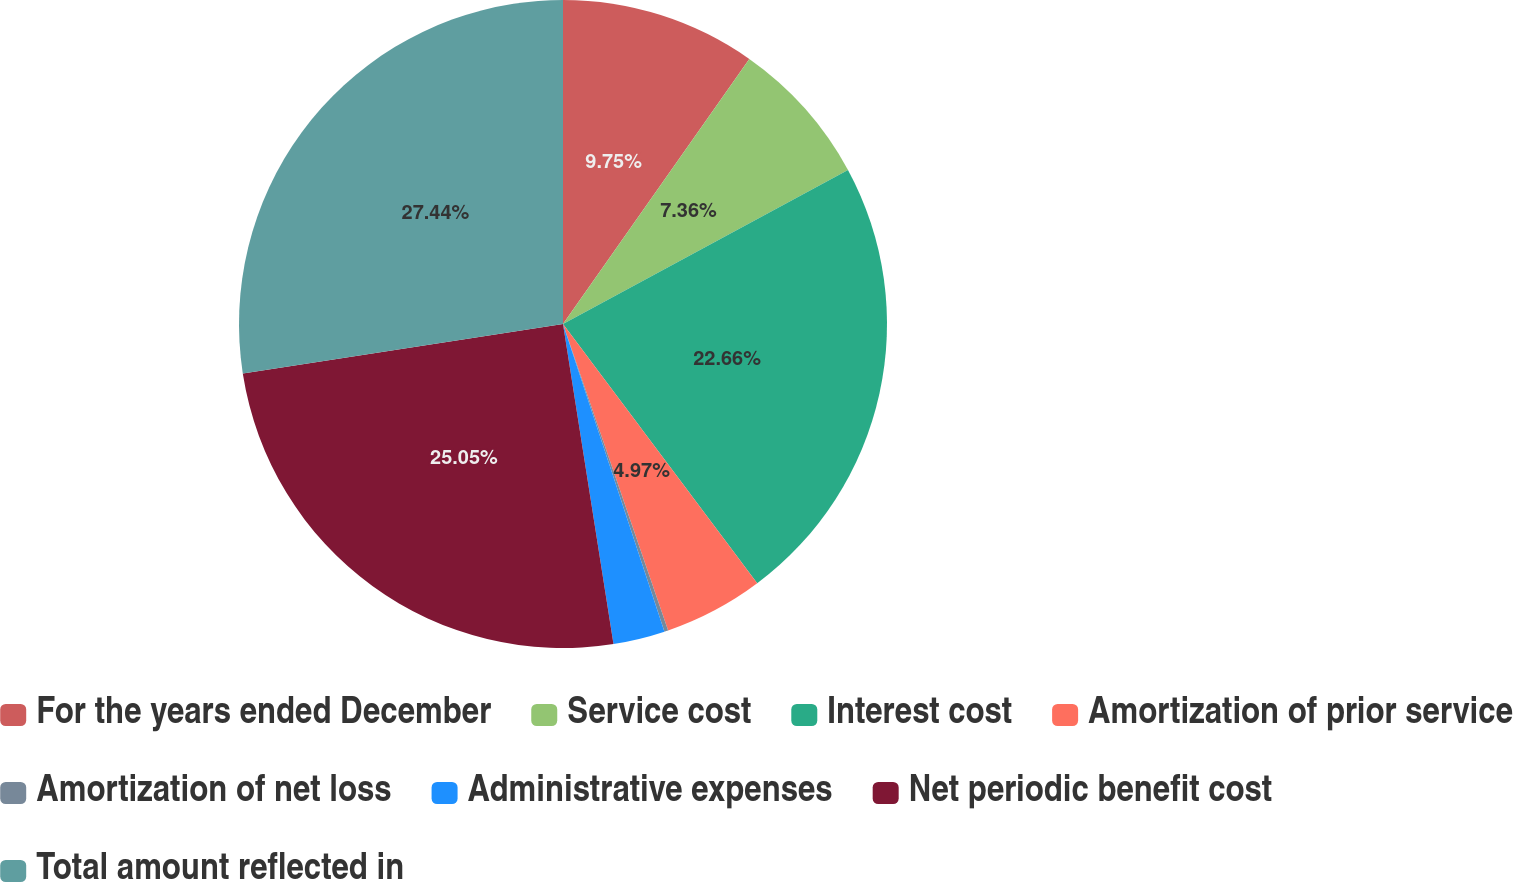Convert chart to OTSL. <chart><loc_0><loc_0><loc_500><loc_500><pie_chart><fcel>For the years ended December<fcel>Service cost<fcel>Interest cost<fcel>Amortization of prior service<fcel>Amortization of net loss<fcel>Administrative expenses<fcel>Net periodic benefit cost<fcel>Total amount reflected in<nl><fcel>9.75%<fcel>7.36%<fcel>22.66%<fcel>4.97%<fcel>0.19%<fcel>2.58%<fcel>25.05%<fcel>27.44%<nl></chart> 